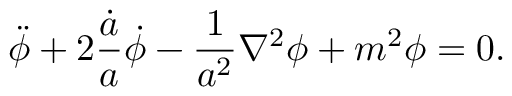<formula> <loc_0><loc_0><loc_500><loc_500>\ddot { \phi } + 2 \frac { \dot { a } } { a } \dot { \phi } - \frac { 1 } { a ^ { 2 } } \nabla ^ { 2 } \phi + m ^ { 2 } \phi = 0 .</formula> 